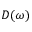Convert formula to latex. <formula><loc_0><loc_0><loc_500><loc_500>D ( \omega )</formula> 